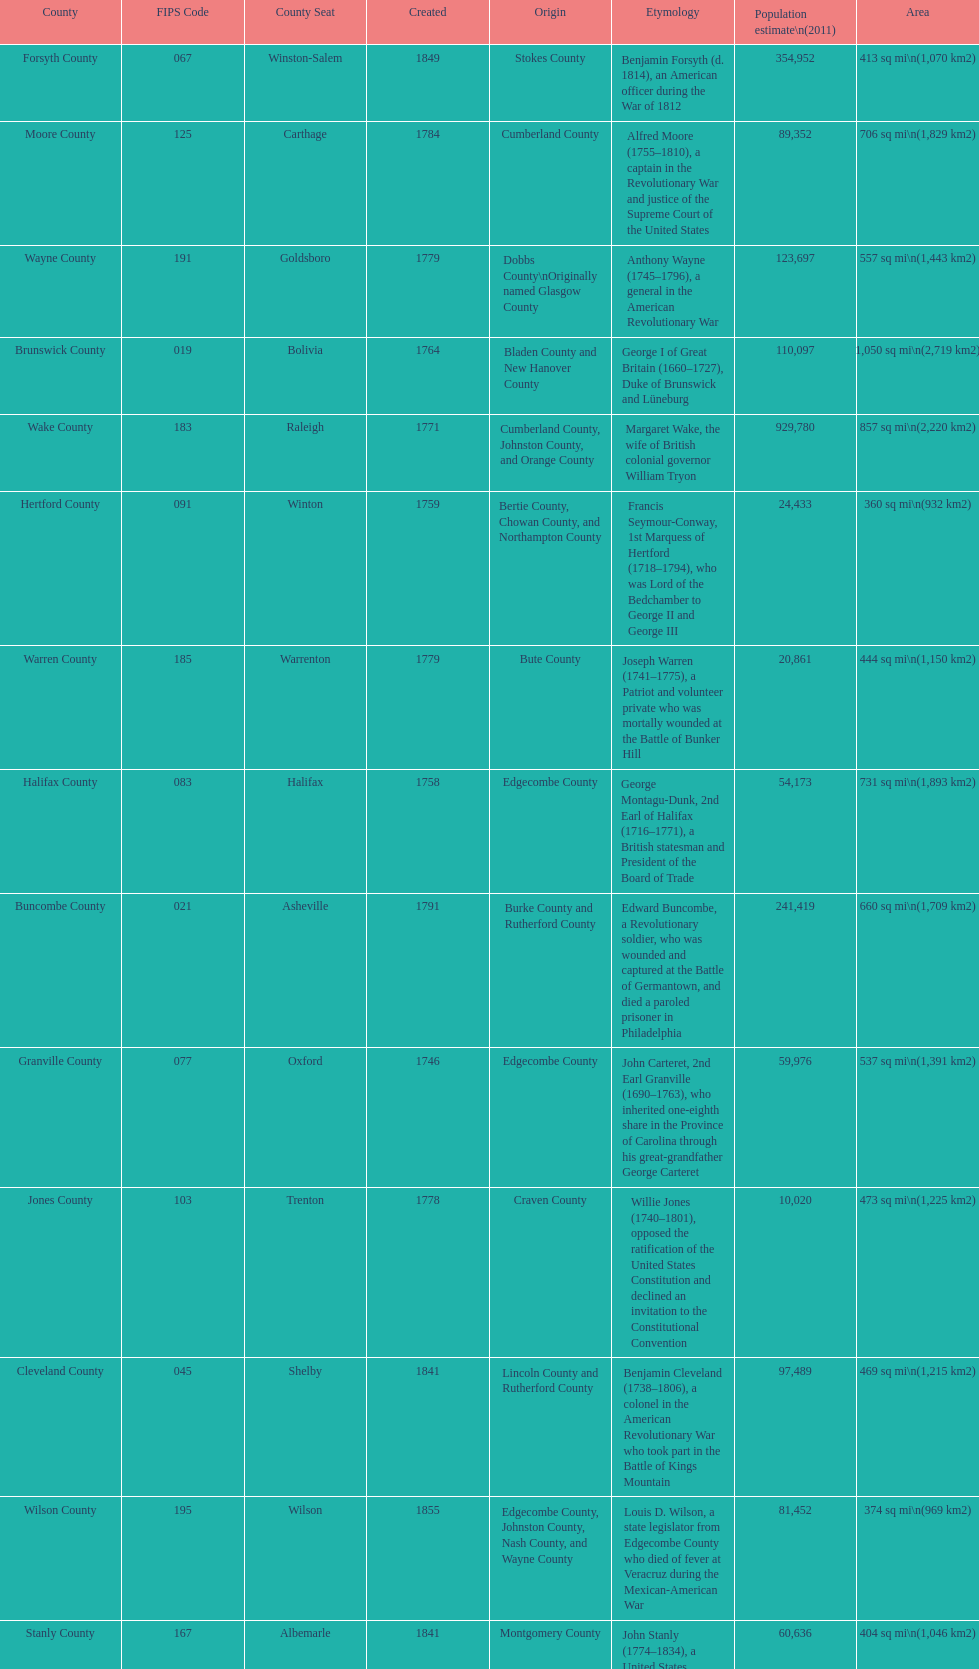What is the total number of counties listed? 100. 